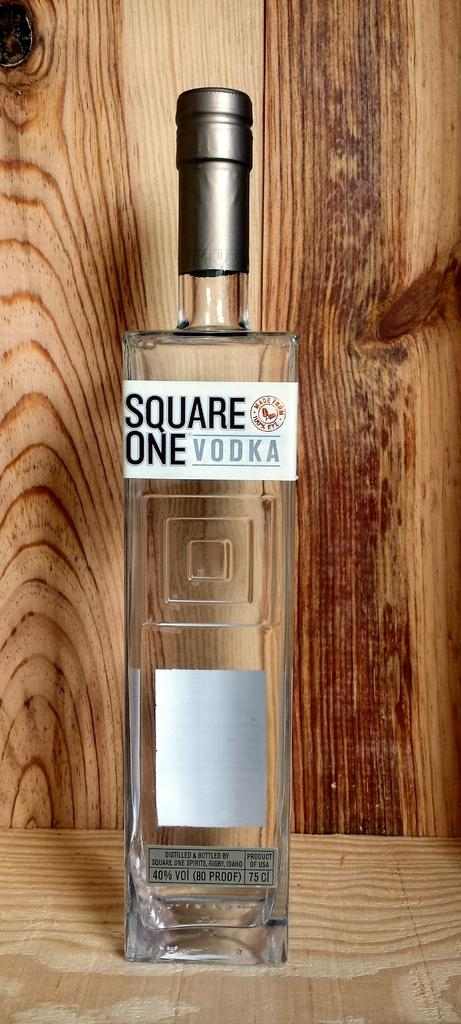<image>
Present a compact description of the photo's key features. A BOTTLE OF VODKA THAT READS SQUARE ONE VODKA 